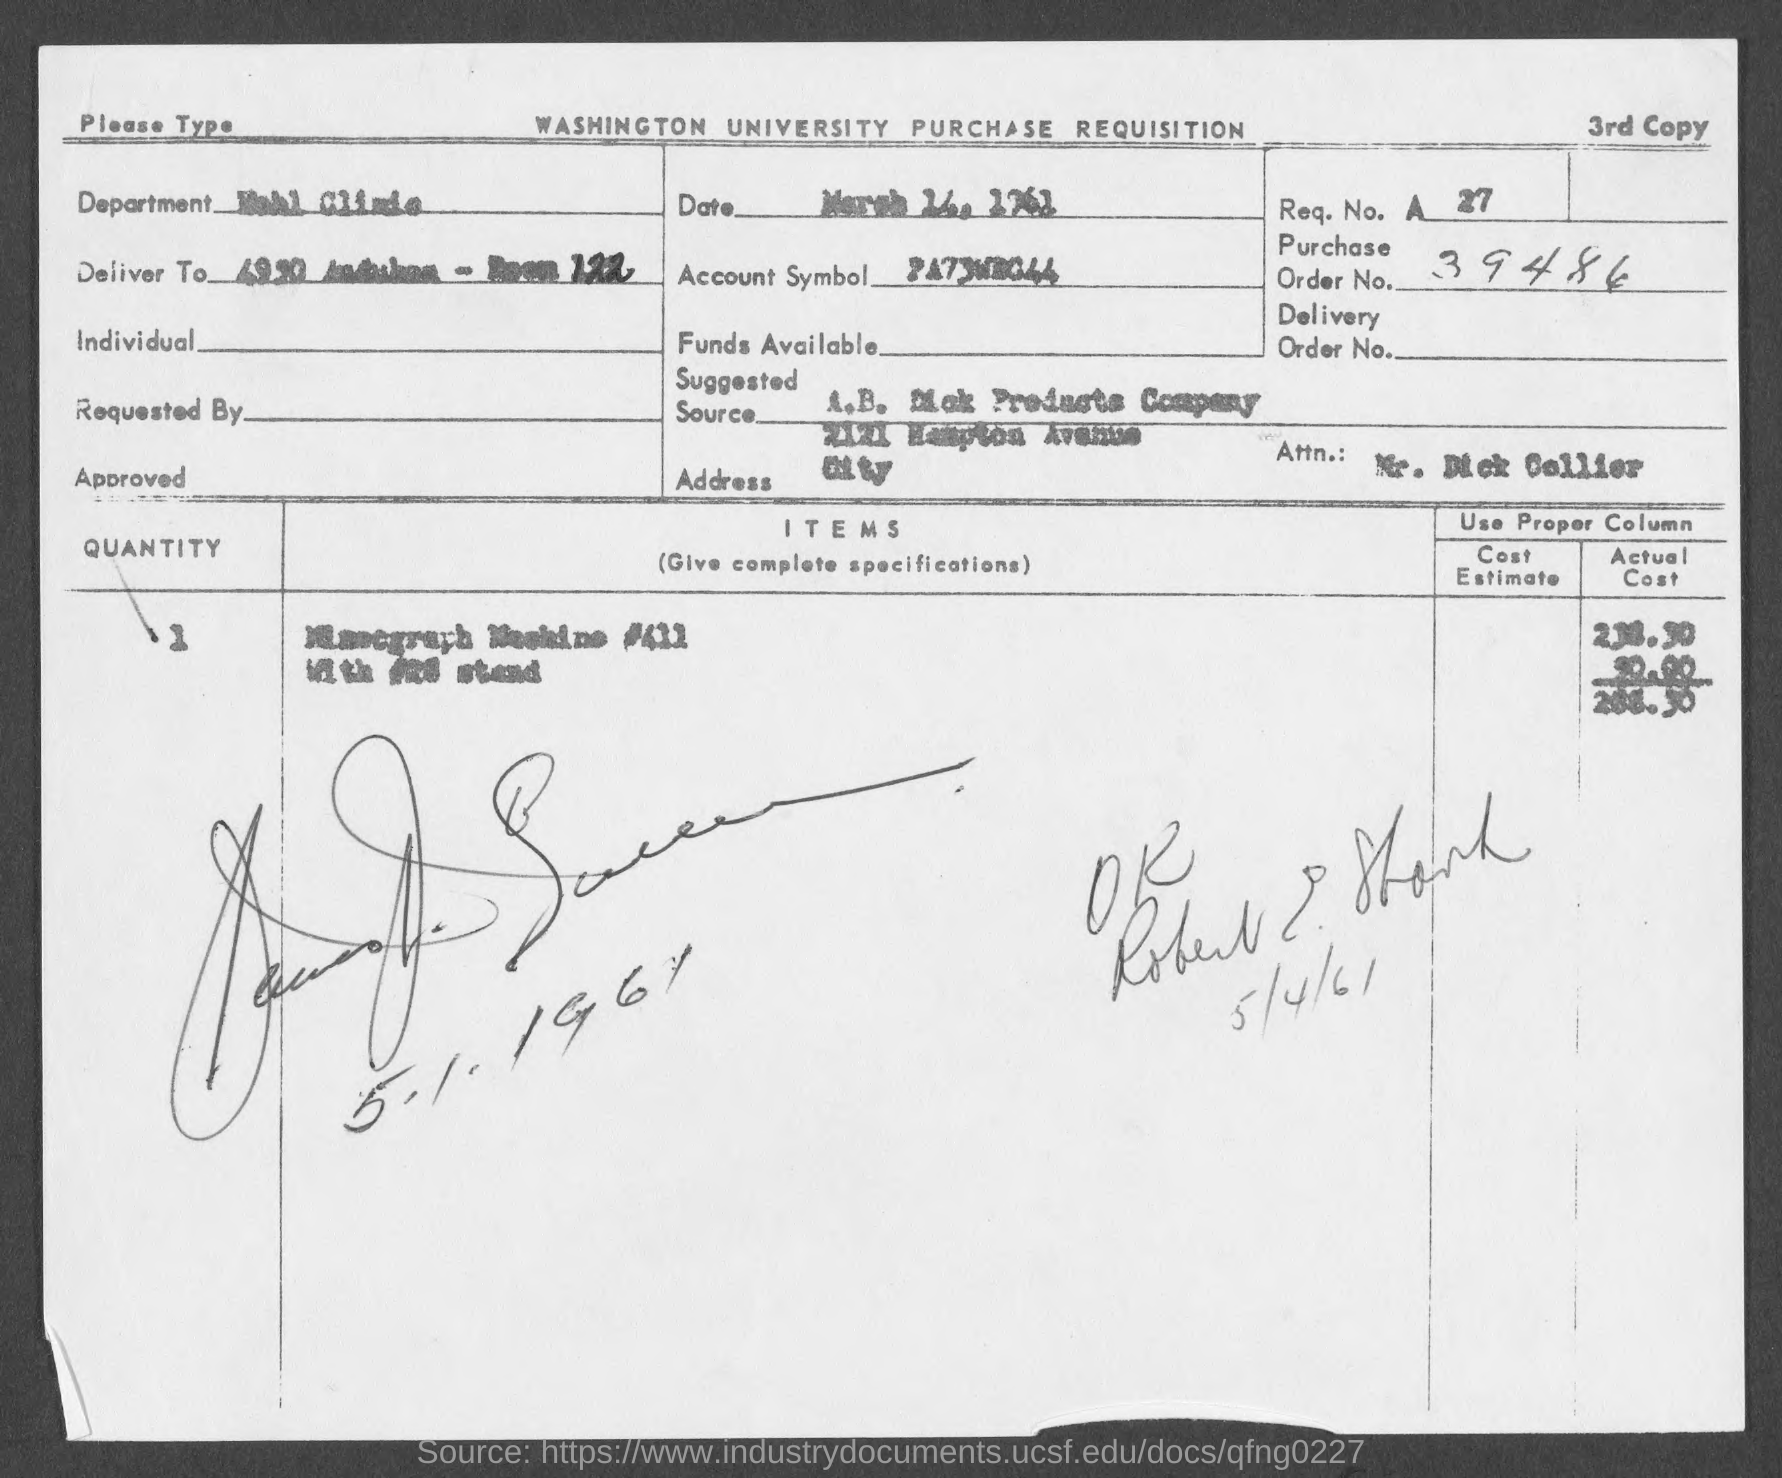What is the Req. No. given in the document?
Your answer should be very brief. A 27. What is the Purchase Order No. given in the document?
Give a very brief answer. 39486. 